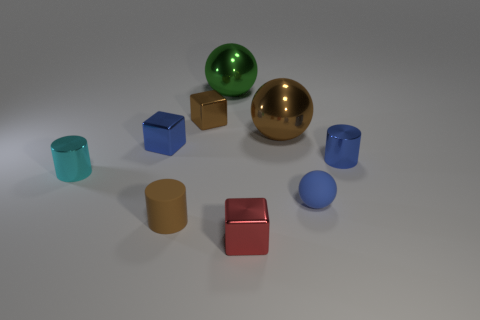Subtract all spheres. How many objects are left? 6 Add 5 small cubes. How many small cubes are left? 8 Add 8 purple metal cubes. How many purple metal cubes exist? 8 Subtract 0 cyan cubes. How many objects are left? 9 Subtract all big brown metallic objects. Subtract all tiny red rubber balls. How many objects are left? 8 